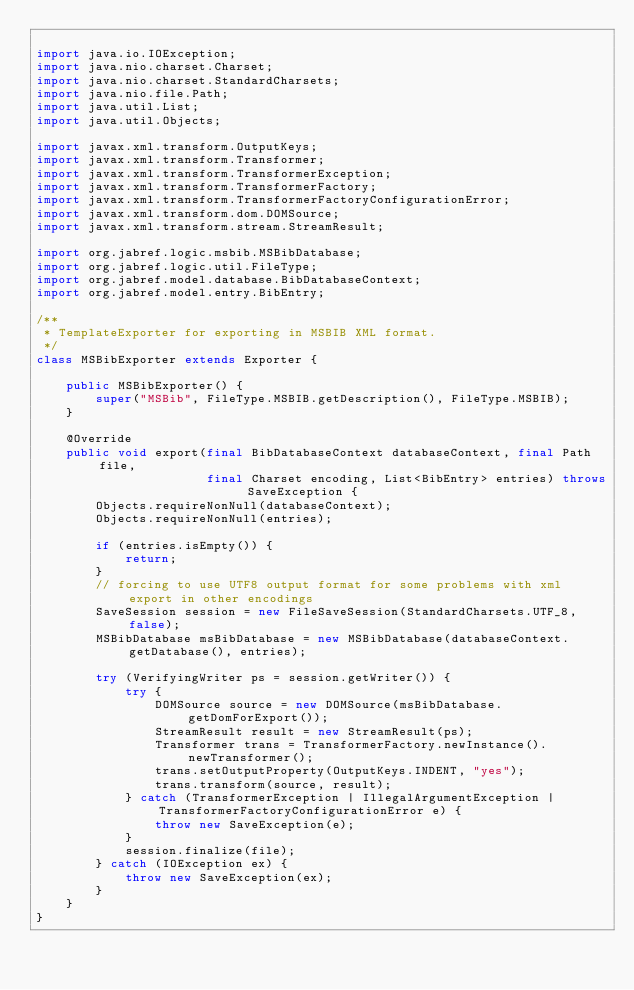<code> <loc_0><loc_0><loc_500><loc_500><_Java_>
import java.io.IOException;
import java.nio.charset.Charset;
import java.nio.charset.StandardCharsets;
import java.nio.file.Path;
import java.util.List;
import java.util.Objects;

import javax.xml.transform.OutputKeys;
import javax.xml.transform.Transformer;
import javax.xml.transform.TransformerException;
import javax.xml.transform.TransformerFactory;
import javax.xml.transform.TransformerFactoryConfigurationError;
import javax.xml.transform.dom.DOMSource;
import javax.xml.transform.stream.StreamResult;

import org.jabref.logic.msbib.MSBibDatabase;
import org.jabref.logic.util.FileType;
import org.jabref.model.database.BibDatabaseContext;
import org.jabref.model.entry.BibEntry;

/**
 * TemplateExporter for exporting in MSBIB XML format.
 */
class MSBibExporter extends Exporter {

    public MSBibExporter() {
        super("MSBib", FileType.MSBIB.getDescription(), FileType.MSBIB);
    }

    @Override
    public void export(final BibDatabaseContext databaseContext, final Path file,
                       final Charset encoding, List<BibEntry> entries) throws SaveException {
        Objects.requireNonNull(databaseContext);
        Objects.requireNonNull(entries);

        if (entries.isEmpty()) {
            return;
        }
        // forcing to use UTF8 output format for some problems with xml export in other encodings
        SaveSession session = new FileSaveSession(StandardCharsets.UTF_8, false);
        MSBibDatabase msBibDatabase = new MSBibDatabase(databaseContext.getDatabase(), entries);

        try (VerifyingWriter ps = session.getWriter()) {
            try {
                DOMSource source = new DOMSource(msBibDatabase.getDomForExport());
                StreamResult result = new StreamResult(ps);
                Transformer trans = TransformerFactory.newInstance().newTransformer();
                trans.setOutputProperty(OutputKeys.INDENT, "yes");
                trans.transform(source, result);
            } catch (TransformerException | IllegalArgumentException | TransformerFactoryConfigurationError e) {
                throw new SaveException(e);
            }
            session.finalize(file);
        } catch (IOException ex) {
            throw new SaveException(ex);
        }
    }
}
</code> 